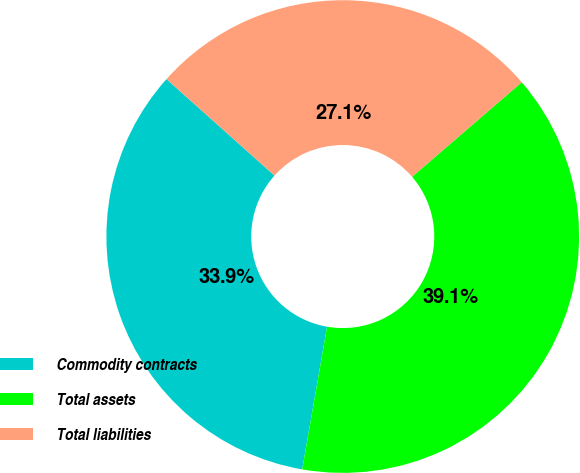Convert chart to OTSL. <chart><loc_0><loc_0><loc_500><loc_500><pie_chart><fcel>Commodity contracts<fcel>Total assets<fcel>Total liabilities<nl><fcel>33.86%<fcel>39.07%<fcel>27.07%<nl></chart> 